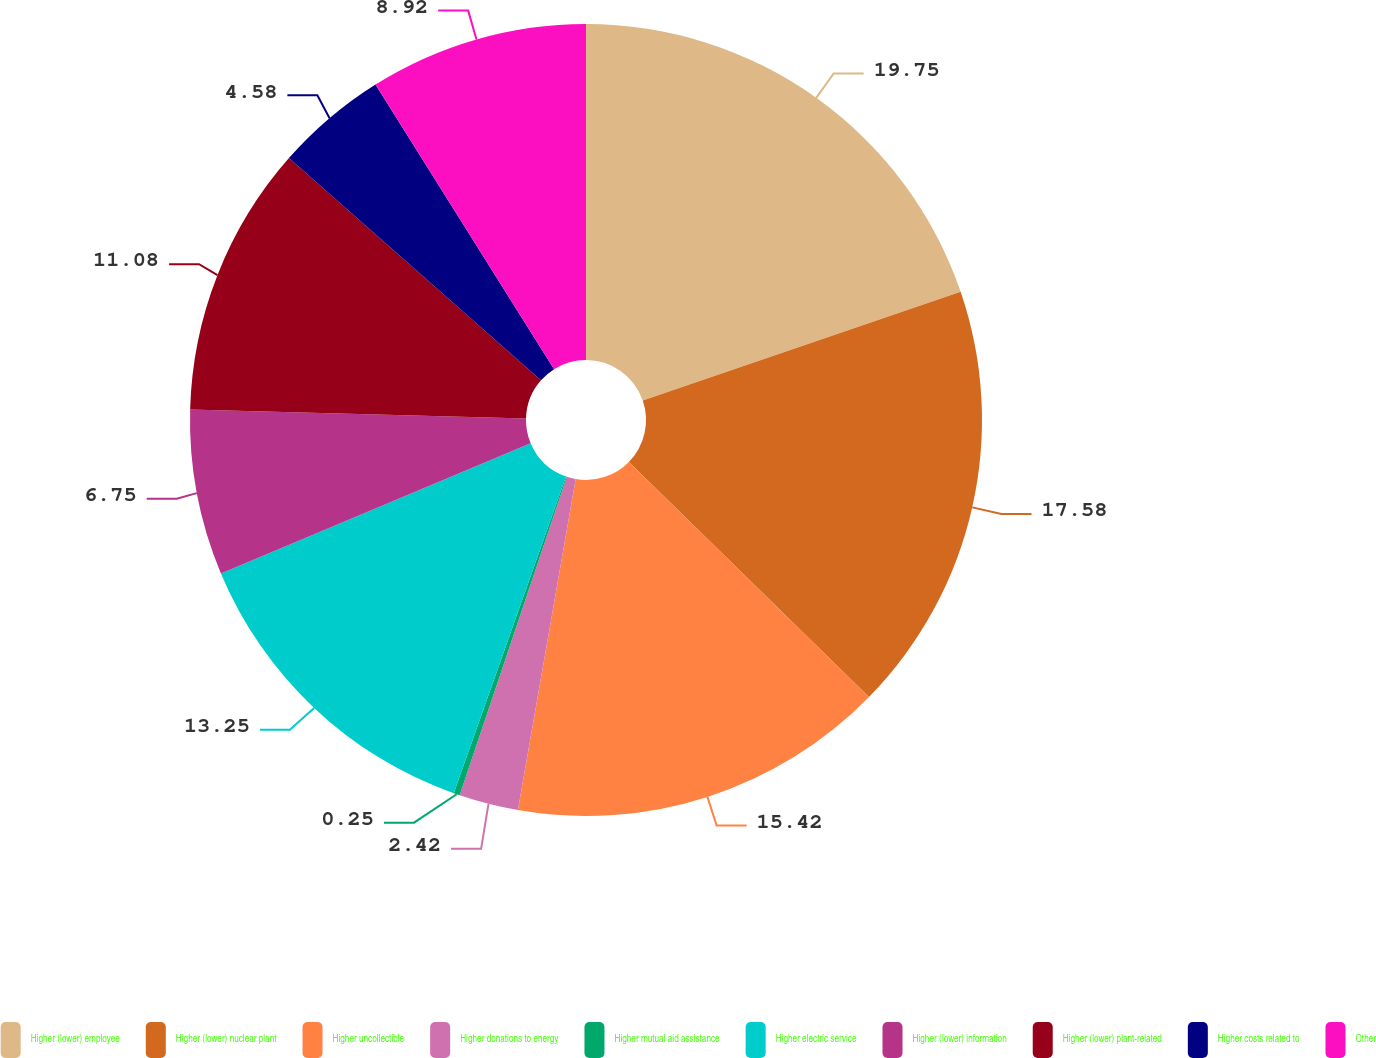<chart> <loc_0><loc_0><loc_500><loc_500><pie_chart><fcel>Higher (lower) employee<fcel>Higher (lower) nuclear plant<fcel>Higher uncollectible<fcel>Higher donations to energy<fcel>Higher mutual aid assistance<fcel>Higher electric service<fcel>Higher (lower) information<fcel>Higher (lower) plant-related<fcel>Higher costs related to<fcel>Other<nl><fcel>19.75%<fcel>17.58%<fcel>15.42%<fcel>2.42%<fcel>0.25%<fcel>13.25%<fcel>6.75%<fcel>11.08%<fcel>4.58%<fcel>8.92%<nl></chart> 